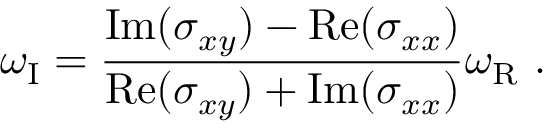Convert formula to latex. <formula><loc_0><loc_0><loc_500><loc_500>\omega _ { I } = \frac { I m ( \sigma _ { x y } ) - R e ( \sigma _ { x x } ) } { R e ( \sigma _ { x y } ) + I m ( \sigma _ { x x } ) } \omega _ { R } \ .</formula> 